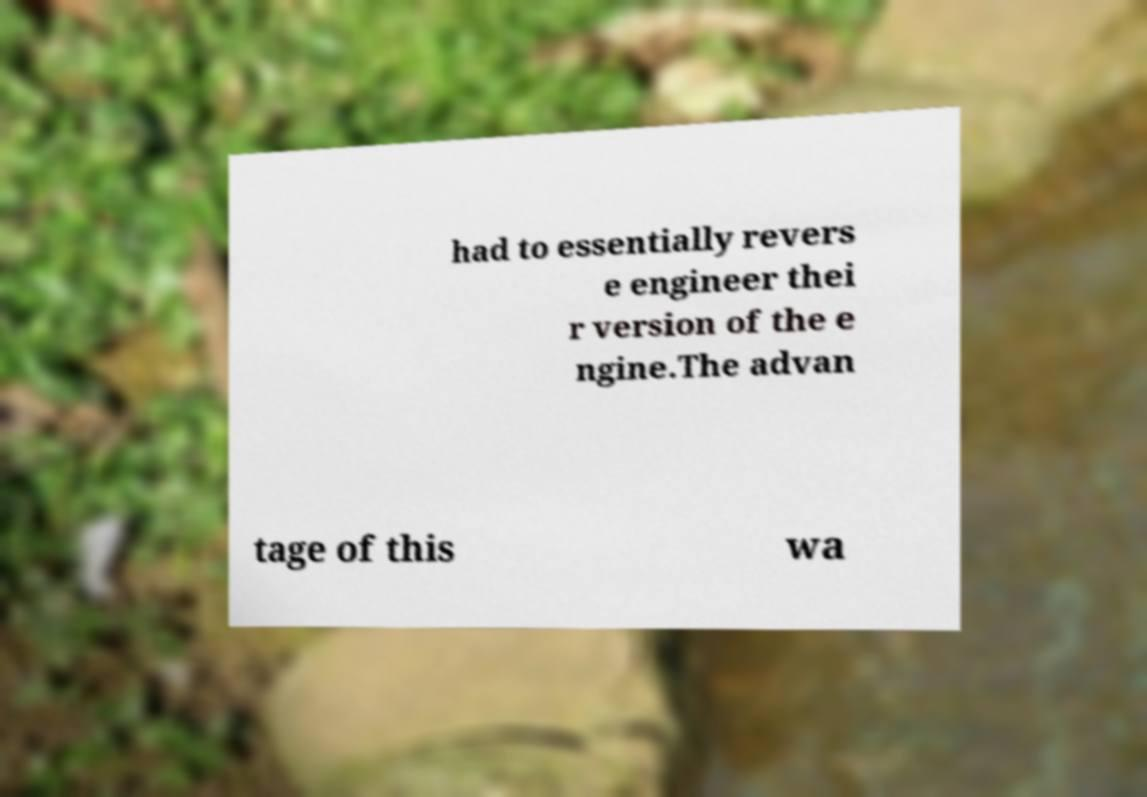Can you accurately transcribe the text from the provided image for me? had to essentially revers e engineer thei r version of the e ngine.The advan tage of this wa 